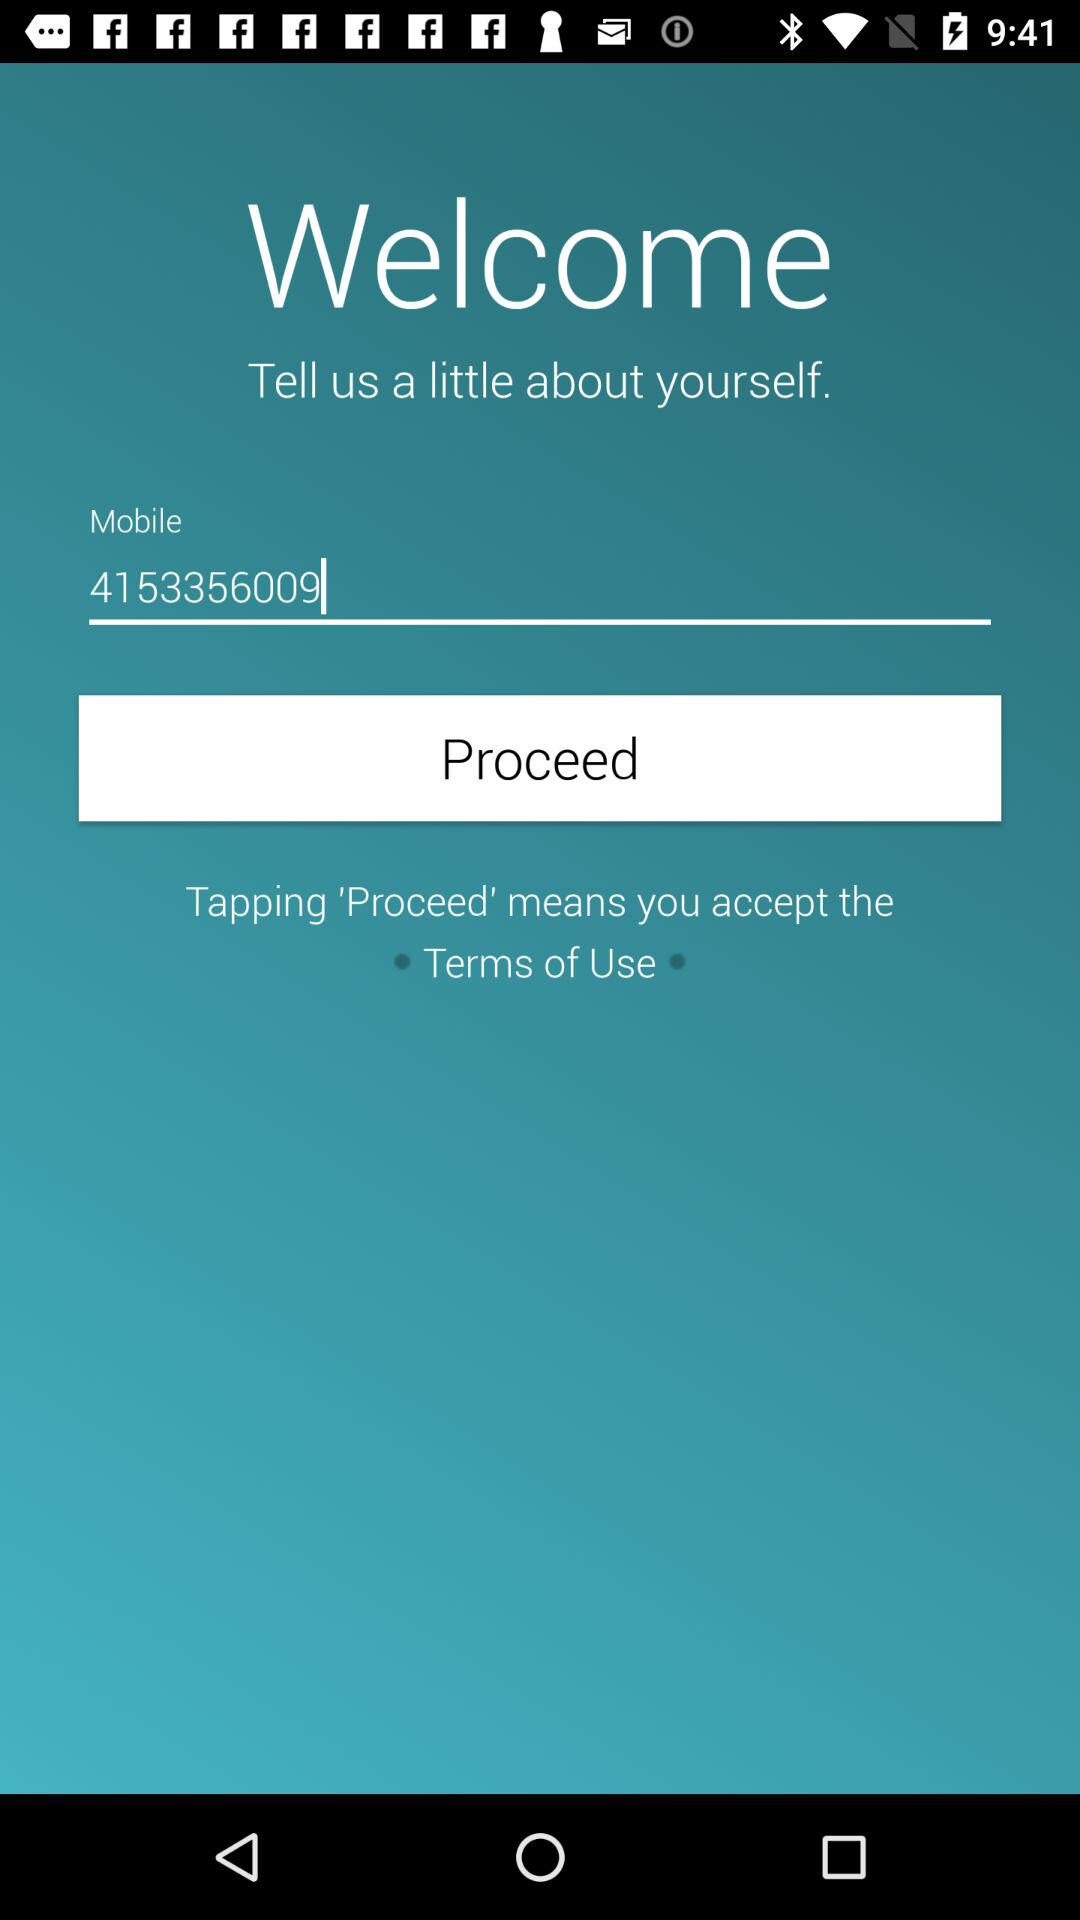What is the mobile number? The mobile number is 4153356009. 